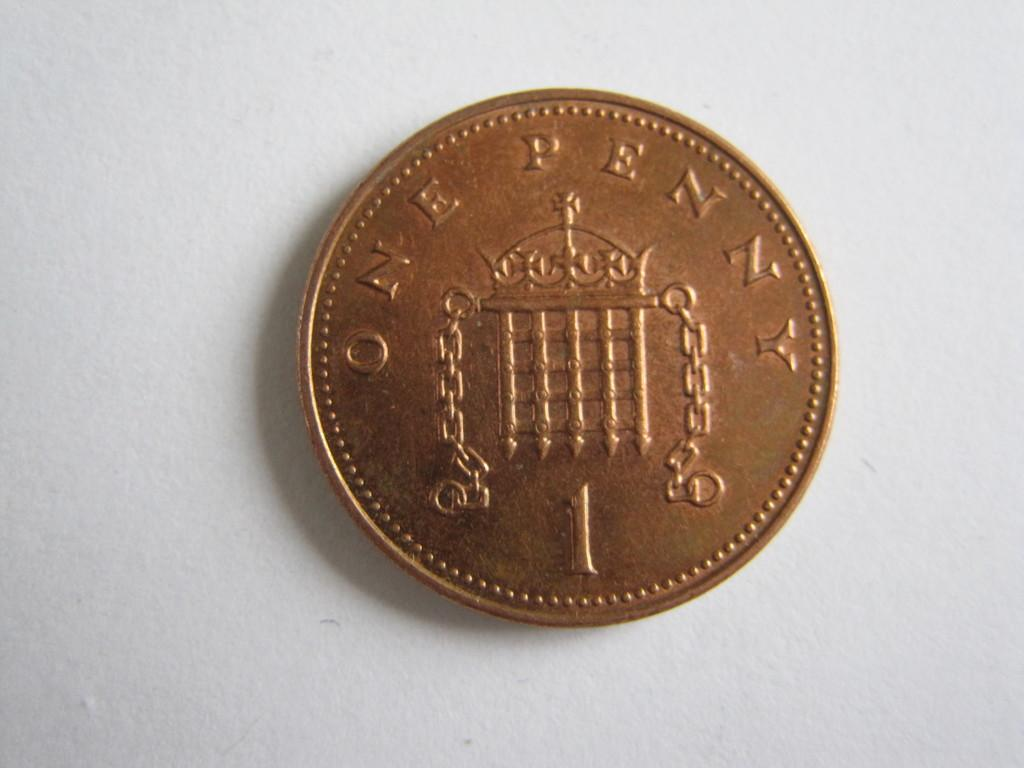<image>
Share a concise interpretation of the image provided. The bronze coin has the words One Penny on the back 